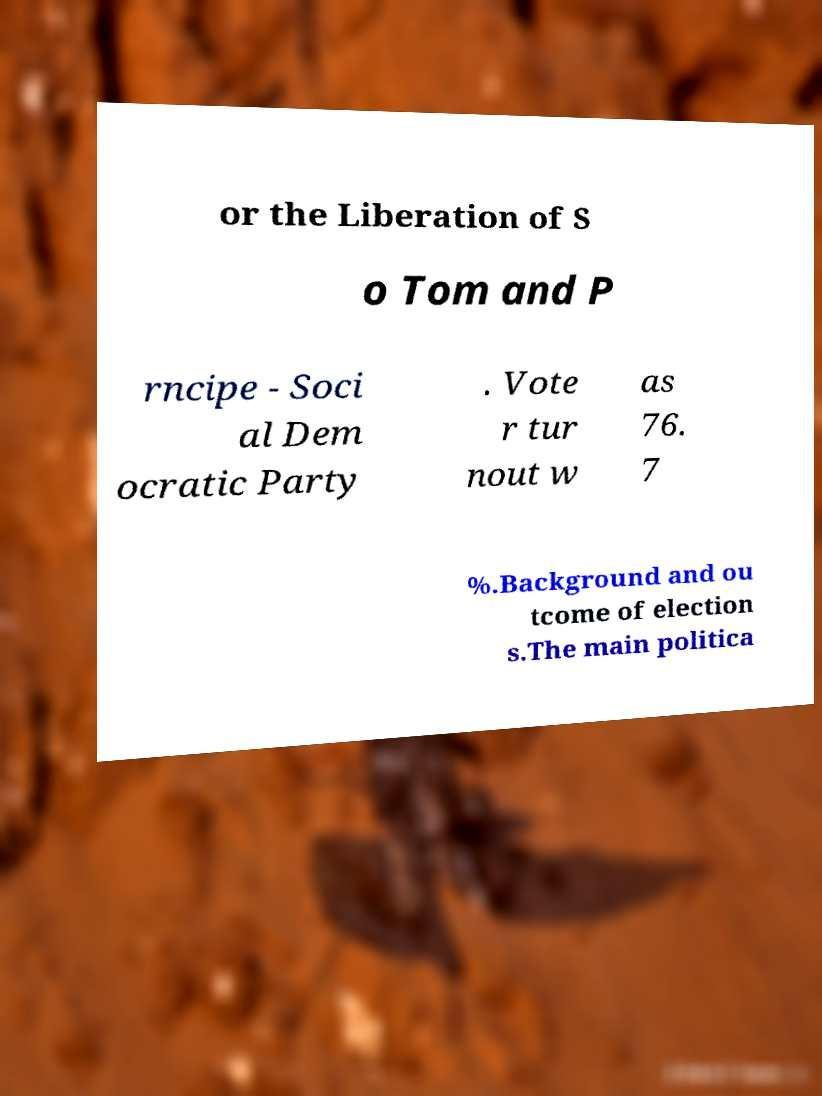Can you read and provide the text displayed in the image?This photo seems to have some interesting text. Can you extract and type it out for me? or the Liberation of S o Tom and P rncipe - Soci al Dem ocratic Party . Vote r tur nout w as 76. 7 %.Background and ou tcome of election s.The main politica 